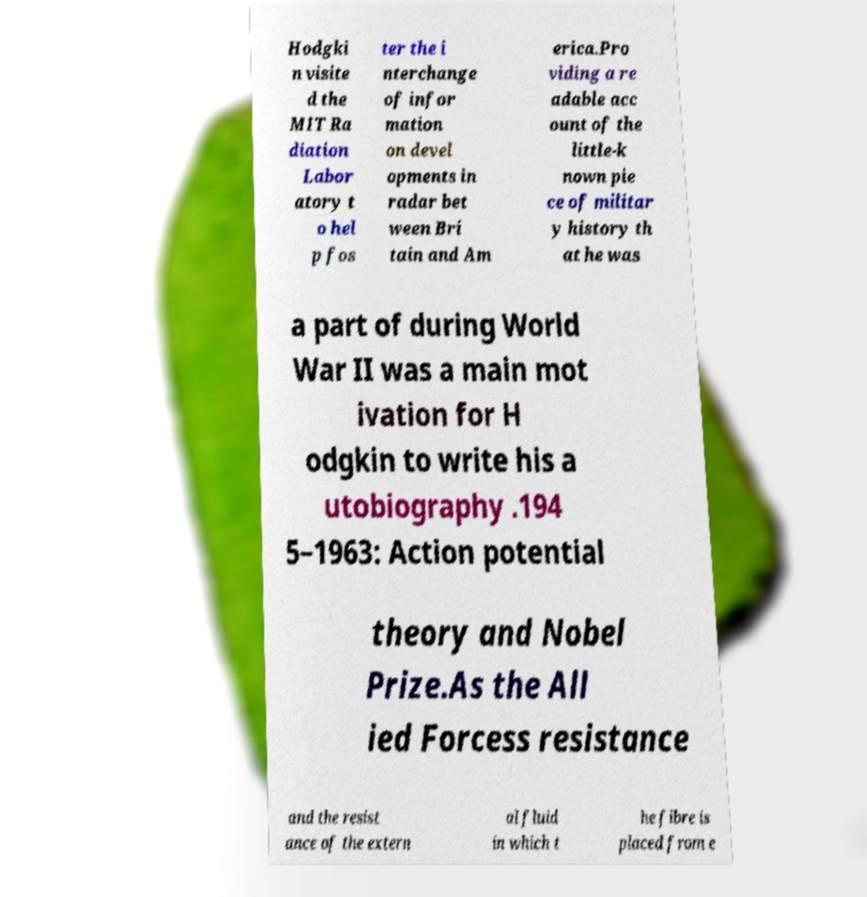For documentation purposes, I need the text within this image transcribed. Could you provide that? Hodgki n visite d the MIT Ra diation Labor atory t o hel p fos ter the i nterchange of infor mation on devel opments in radar bet ween Bri tain and Am erica.Pro viding a re adable acc ount of the little-k nown pie ce of militar y history th at he was a part of during World War II was a main mot ivation for H odgkin to write his a utobiography .194 5–1963: Action potential theory and Nobel Prize.As the All ied Forcess resistance and the resist ance of the extern al fluid in which t he fibre is placed from e 